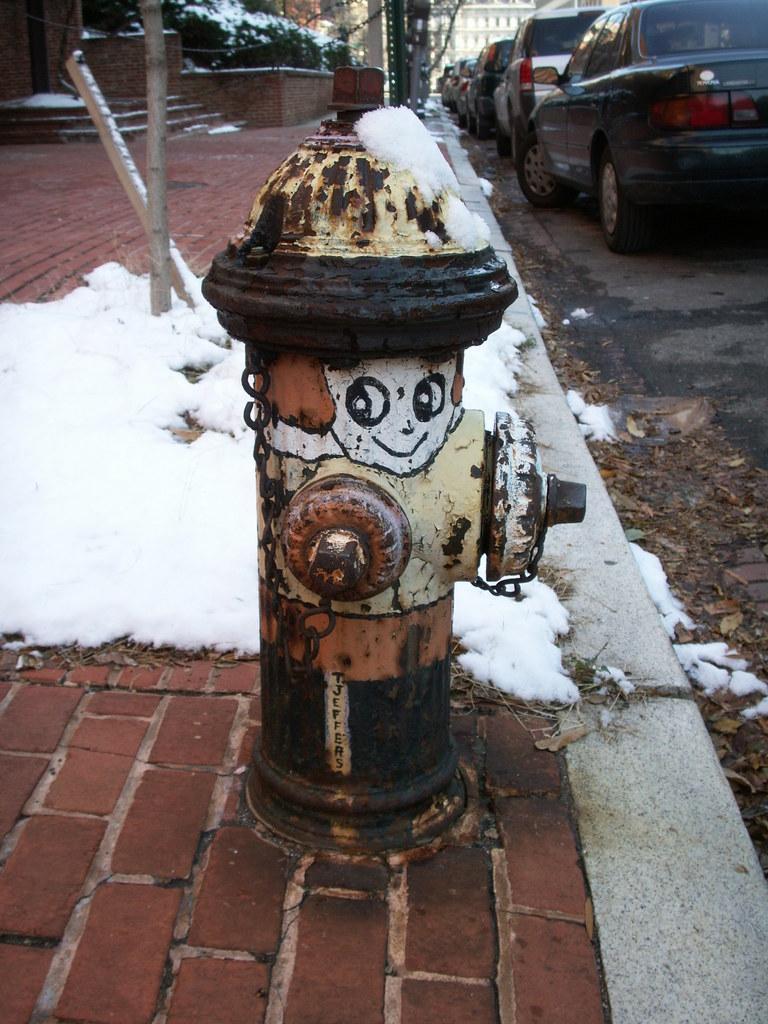In one or two sentences, can you explain what this image depicts? There is a sidewalk. On that there is a white color thing, poles and a standpipe. Near to that there is a road. On that there are vehicles. 